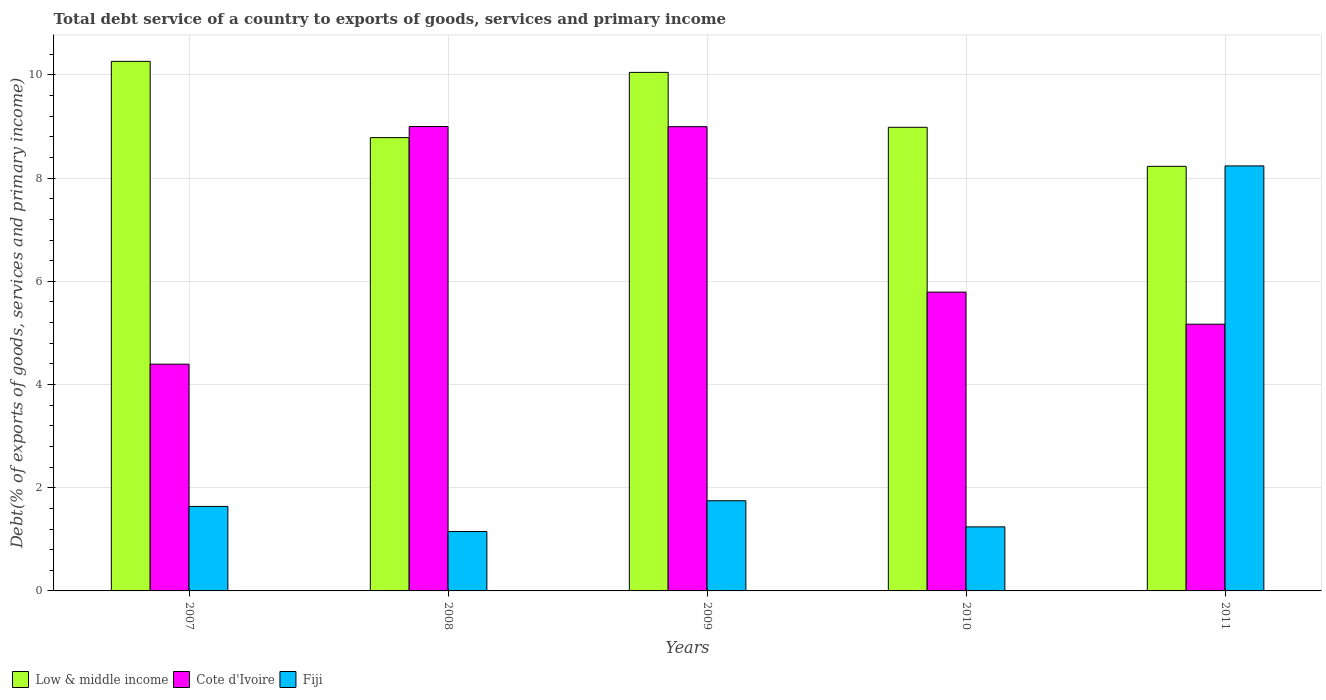How many groups of bars are there?
Your response must be concise. 5. Are the number of bars per tick equal to the number of legend labels?
Offer a terse response. Yes. How many bars are there on the 4th tick from the left?
Offer a very short reply. 3. What is the label of the 2nd group of bars from the left?
Make the answer very short. 2008. What is the total debt service in Cote d'Ivoire in 2009?
Provide a short and direct response. 9. Across all years, what is the maximum total debt service in Low & middle income?
Ensure brevity in your answer.  10.26. Across all years, what is the minimum total debt service in Low & middle income?
Your answer should be very brief. 8.23. In which year was the total debt service in Cote d'Ivoire minimum?
Your answer should be compact. 2007. What is the total total debt service in Fiji in the graph?
Provide a succinct answer. 14.02. What is the difference between the total debt service in Cote d'Ivoire in 2009 and that in 2010?
Provide a succinct answer. 3.21. What is the difference between the total debt service in Low & middle income in 2008 and the total debt service in Cote d'Ivoire in 2010?
Keep it short and to the point. 2.99. What is the average total debt service in Low & middle income per year?
Your answer should be very brief. 9.26. In the year 2007, what is the difference between the total debt service in Fiji and total debt service in Cote d'Ivoire?
Make the answer very short. -2.76. In how many years, is the total debt service in Cote d'Ivoire greater than 9.6 %?
Keep it short and to the point. 0. What is the ratio of the total debt service in Cote d'Ivoire in 2008 to that in 2011?
Make the answer very short. 1.74. What is the difference between the highest and the second highest total debt service in Fiji?
Ensure brevity in your answer.  6.49. What is the difference between the highest and the lowest total debt service in Fiji?
Your response must be concise. 7.09. Is the sum of the total debt service in Cote d'Ivoire in 2007 and 2011 greater than the maximum total debt service in Fiji across all years?
Keep it short and to the point. Yes. What does the 1st bar from the right in 2009 represents?
Your answer should be very brief. Fiji. What is the difference between two consecutive major ticks on the Y-axis?
Keep it short and to the point. 2. How many legend labels are there?
Offer a very short reply. 3. What is the title of the graph?
Offer a terse response. Total debt service of a country to exports of goods, services and primary income. What is the label or title of the Y-axis?
Your answer should be compact. Debt(% of exports of goods, services and primary income). What is the Debt(% of exports of goods, services and primary income) in Low & middle income in 2007?
Offer a very short reply. 10.26. What is the Debt(% of exports of goods, services and primary income) of Cote d'Ivoire in 2007?
Offer a terse response. 4.39. What is the Debt(% of exports of goods, services and primary income) of Fiji in 2007?
Make the answer very short. 1.64. What is the Debt(% of exports of goods, services and primary income) of Low & middle income in 2008?
Keep it short and to the point. 8.79. What is the Debt(% of exports of goods, services and primary income) in Cote d'Ivoire in 2008?
Make the answer very short. 9. What is the Debt(% of exports of goods, services and primary income) of Fiji in 2008?
Your answer should be very brief. 1.15. What is the Debt(% of exports of goods, services and primary income) of Low & middle income in 2009?
Your response must be concise. 10.05. What is the Debt(% of exports of goods, services and primary income) in Cote d'Ivoire in 2009?
Provide a short and direct response. 9. What is the Debt(% of exports of goods, services and primary income) in Fiji in 2009?
Make the answer very short. 1.75. What is the Debt(% of exports of goods, services and primary income) in Low & middle income in 2010?
Provide a short and direct response. 8.99. What is the Debt(% of exports of goods, services and primary income) of Cote d'Ivoire in 2010?
Provide a short and direct response. 5.79. What is the Debt(% of exports of goods, services and primary income) in Fiji in 2010?
Give a very brief answer. 1.24. What is the Debt(% of exports of goods, services and primary income) in Low & middle income in 2011?
Keep it short and to the point. 8.23. What is the Debt(% of exports of goods, services and primary income) of Cote d'Ivoire in 2011?
Make the answer very short. 5.17. What is the Debt(% of exports of goods, services and primary income) of Fiji in 2011?
Your answer should be very brief. 8.24. Across all years, what is the maximum Debt(% of exports of goods, services and primary income) of Low & middle income?
Provide a short and direct response. 10.26. Across all years, what is the maximum Debt(% of exports of goods, services and primary income) in Cote d'Ivoire?
Ensure brevity in your answer.  9. Across all years, what is the maximum Debt(% of exports of goods, services and primary income) of Fiji?
Provide a succinct answer. 8.24. Across all years, what is the minimum Debt(% of exports of goods, services and primary income) of Low & middle income?
Offer a terse response. 8.23. Across all years, what is the minimum Debt(% of exports of goods, services and primary income) in Cote d'Ivoire?
Offer a very short reply. 4.39. Across all years, what is the minimum Debt(% of exports of goods, services and primary income) in Fiji?
Give a very brief answer. 1.15. What is the total Debt(% of exports of goods, services and primary income) in Low & middle income in the graph?
Offer a terse response. 46.31. What is the total Debt(% of exports of goods, services and primary income) of Cote d'Ivoire in the graph?
Provide a short and direct response. 33.35. What is the total Debt(% of exports of goods, services and primary income) of Fiji in the graph?
Ensure brevity in your answer.  14.02. What is the difference between the Debt(% of exports of goods, services and primary income) in Low & middle income in 2007 and that in 2008?
Offer a very short reply. 1.48. What is the difference between the Debt(% of exports of goods, services and primary income) in Cote d'Ivoire in 2007 and that in 2008?
Ensure brevity in your answer.  -4.61. What is the difference between the Debt(% of exports of goods, services and primary income) of Fiji in 2007 and that in 2008?
Your response must be concise. 0.49. What is the difference between the Debt(% of exports of goods, services and primary income) in Low & middle income in 2007 and that in 2009?
Provide a succinct answer. 0.21. What is the difference between the Debt(% of exports of goods, services and primary income) of Cote d'Ivoire in 2007 and that in 2009?
Your answer should be very brief. -4.6. What is the difference between the Debt(% of exports of goods, services and primary income) of Fiji in 2007 and that in 2009?
Give a very brief answer. -0.11. What is the difference between the Debt(% of exports of goods, services and primary income) of Low & middle income in 2007 and that in 2010?
Provide a succinct answer. 1.28. What is the difference between the Debt(% of exports of goods, services and primary income) in Cote d'Ivoire in 2007 and that in 2010?
Provide a succinct answer. -1.4. What is the difference between the Debt(% of exports of goods, services and primary income) of Fiji in 2007 and that in 2010?
Your answer should be very brief. 0.4. What is the difference between the Debt(% of exports of goods, services and primary income) of Low & middle income in 2007 and that in 2011?
Provide a succinct answer. 2.03. What is the difference between the Debt(% of exports of goods, services and primary income) in Cote d'Ivoire in 2007 and that in 2011?
Your answer should be very brief. -0.77. What is the difference between the Debt(% of exports of goods, services and primary income) in Fiji in 2007 and that in 2011?
Offer a terse response. -6.6. What is the difference between the Debt(% of exports of goods, services and primary income) in Low & middle income in 2008 and that in 2009?
Offer a terse response. -1.26. What is the difference between the Debt(% of exports of goods, services and primary income) in Cote d'Ivoire in 2008 and that in 2009?
Your answer should be very brief. 0. What is the difference between the Debt(% of exports of goods, services and primary income) of Fiji in 2008 and that in 2009?
Provide a short and direct response. -0.6. What is the difference between the Debt(% of exports of goods, services and primary income) in Low & middle income in 2008 and that in 2010?
Offer a terse response. -0.2. What is the difference between the Debt(% of exports of goods, services and primary income) of Cote d'Ivoire in 2008 and that in 2010?
Provide a succinct answer. 3.21. What is the difference between the Debt(% of exports of goods, services and primary income) in Fiji in 2008 and that in 2010?
Ensure brevity in your answer.  -0.09. What is the difference between the Debt(% of exports of goods, services and primary income) in Low & middle income in 2008 and that in 2011?
Give a very brief answer. 0.56. What is the difference between the Debt(% of exports of goods, services and primary income) of Cote d'Ivoire in 2008 and that in 2011?
Keep it short and to the point. 3.83. What is the difference between the Debt(% of exports of goods, services and primary income) of Fiji in 2008 and that in 2011?
Keep it short and to the point. -7.09. What is the difference between the Debt(% of exports of goods, services and primary income) of Low & middle income in 2009 and that in 2010?
Your answer should be very brief. 1.06. What is the difference between the Debt(% of exports of goods, services and primary income) of Cote d'Ivoire in 2009 and that in 2010?
Provide a succinct answer. 3.21. What is the difference between the Debt(% of exports of goods, services and primary income) in Fiji in 2009 and that in 2010?
Offer a terse response. 0.51. What is the difference between the Debt(% of exports of goods, services and primary income) in Low & middle income in 2009 and that in 2011?
Keep it short and to the point. 1.82. What is the difference between the Debt(% of exports of goods, services and primary income) of Cote d'Ivoire in 2009 and that in 2011?
Your answer should be very brief. 3.83. What is the difference between the Debt(% of exports of goods, services and primary income) in Fiji in 2009 and that in 2011?
Your response must be concise. -6.49. What is the difference between the Debt(% of exports of goods, services and primary income) in Low & middle income in 2010 and that in 2011?
Offer a terse response. 0.76. What is the difference between the Debt(% of exports of goods, services and primary income) in Cote d'Ivoire in 2010 and that in 2011?
Make the answer very short. 0.62. What is the difference between the Debt(% of exports of goods, services and primary income) in Fiji in 2010 and that in 2011?
Your answer should be compact. -7. What is the difference between the Debt(% of exports of goods, services and primary income) of Low & middle income in 2007 and the Debt(% of exports of goods, services and primary income) of Cote d'Ivoire in 2008?
Your response must be concise. 1.26. What is the difference between the Debt(% of exports of goods, services and primary income) of Low & middle income in 2007 and the Debt(% of exports of goods, services and primary income) of Fiji in 2008?
Offer a very short reply. 9.11. What is the difference between the Debt(% of exports of goods, services and primary income) in Cote d'Ivoire in 2007 and the Debt(% of exports of goods, services and primary income) in Fiji in 2008?
Make the answer very short. 3.24. What is the difference between the Debt(% of exports of goods, services and primary income) in Low & middle income in 2007 and the Debt(% of exports of goods, services and primary income) in Cote d'Ivoire in 2009?
Make the answer very short. 1.27. What is the difference between the Debt(% of exports of goods, services and primary income) of Low & middle income in 2007 and the Debt(% of exports of goods, services and primary income) of Fiji in 2009?
Make the answer very short. 8.52. What is the difference between the Debt(% of exports of goods, services and primary income) of Cote d'Ivoire in 2007 and the Debt(% of exports of goods, services and primary income) of Fiji in 2009?
Your response must be concise. 2.65. What is the difference between the Debt(% of exports of goods, services and primary income) in Low & middle income in 2007 and the Debt(% of exports of goods, services and primary income) in Cote d'Ivoire in 2010?
Keep it short and to the point. 4.47. What is the difference between the Debt(% of exports of goods, services and primary income) of Low & middle income in 2007 and the Debt(% of exports of goods, services and primary income) of Fiji in 2010?
Give a very brief answer. 9.02. What is the difference between the Debt(% of exports of goods, services and primary income) in Cote d'Ivoire in 2007 and the Debt(% of exports of goods, services and primary income) in Fiji in 2010?
Provide a succinct answer. 3.15. What is the difference between the Debt(% of exports of goods, services and primary income) in Low & middle income in 2007 and the Debt(% of exports of goods, services and primary income) in Cote d'Ivoire in 2011?
Your response must be concise. 5.09. What is the difference between the Debt(% of exports of goods, services and primary income) of Low & middle income in 2007 and the Debt(% of exports of goods, services and primary income) of Fiji in 2011?
Provide a short and direct response. 2.03. What is the difference between the Debt(% of exports of goods, services and primary income) in Cote d'Ivoire in 2007 and the Debt(% of exports of goods, services and primary income) in Fiji in 2011?
Your answer should be compact. -3.84. What is the difference between the Debt(% of exports of goods, services and primary income) of Low & middle income in 2008 and the Debt(% of exports of goods, services and primary income) of Cote d'Ivoire in 2009?
Provide a short and direct response. -0.21. What is the difference between the Debt(% of exports of goods, services and primary income) in Low & middle income in 2008 and the Debt(% of exports of goods, services and primary income) in Fiji in 2009?
Provide a short and direct response. 7.04. What is the difference between the Debt(% of exports of goods, services and primary income) in Cote d'Ivoire in 2008 and the Debt(% of exports of goods, services and primary income) in Fiji in 2009?
Your answer should be very brief. 7.25. What is the difference between the Debt(% of exports of goods, services and primary income) of Low & middle income in 2008 and the Debt(% of exports of goods, services and primary income) of Cote d'Ivoire in 2010?
Offer a terse response. 2.99. What is the difference between the Debt(% of exports of goods, services and primary income) in Low & middle income in 2008 and the Debt(% of exports of goods, services and primary income) in Fiji in 2010?
Your answer should be compact. 7.54. What is the difference between the Debt(% of exports of goods, services and primary income) in Cote d'Ivoire in 2008 and the Debt(% of exports of goods, services and primary income) in Fiji in 2010?
Your answer should be very brief. 7.76. What is the difference between the Debt(% of exports of goods, services and primary income) of Low & middle income in 2008 and the Debt(% of exports of goods, services and primary income) of Cote d'Ivoire in 2011?
Your response must be concise. 3.62. What is the difference between the Debt(% of exports of goods, services and primary income) of Low & middle income in 2008 and the Debt(% of exports of goods, services and primary income) of Fiji in 2011?
Offer a terse response. 0.55. What is the difference between the Debt(% of exports of goods, services and primary income) of Cote d'Ivoire in 2008 and the Debt(% of exports of goods, services and primary income) of Fiji in 2011?
Offer a terse response. 0.76. What is the difference between the Debt(% of exports of goods, services and primary income) in Low & middle income in 2009 and the Debt(% of exports of goods, services and primary income) in Cote d'Ivoire in 2010?
Your answer should be very brief. 4.26. What is the difference between the Debt(% of exports of goods, services and primary income) in Low & middle income in 2009 and the Debt(% of exports of goods, services and primary income) in Fiji in 2010?
Offer a terse response. 8.81. What is the difference between the Debt(% of exports of goods, services and primary income) in Cote d'Ivoire in 2009 and the Debt(% of exports of goods, services and primary income) in Fiji in 2010?
Your answer should be very brief. 7.76. What is the difference between the Debt(% of exports of goods, services and primary income) in Low & middle income in 2009 and the Debt(% of exports of goods, services and primary income) in Cote d'Ivoire in 2011?
Make the answer very short. 4.88. What is the difference between the Debt(% of exports of goods, services and primary income) in Low & middle income in 2009 and the Debt(% of exports of goods, services and primary income) in Fiji in 2011?
Offer a very short reply. 1.81. What is the difference between the Debt(% of exports of goods, services and primary income) of Cote d'Ivoire in 2009 and the Debt(% of exports of goods, services and primary income) of Fiji in 2011?
Your answer should be compact. 0.76. What is the difference between the Debt(% of exports of goods, services and primary income) in Low & middle income in 2010 and the Debt(% of exports of goods, services and primary income) in Cote d'Ivoire in 2011?
Offer a very short reply. 3.82. What is the difference between the Debt(% of exports of goods, services and primary income) in Low & middle income in 2010 and the Debt(% of exports of goods, services and primary income) in Fiji in 2011?
Provide a short and direct response. 0.75. What is the difference between the Debt(% of exports of goods, services and primary income) in Cote d'Ivoire in 2010 and the Debt(% of exports of goods, services and primary income) in Fiji in 2011?
Your answer should be compact. -2.45. What is the average Debt(% of exports of goods, services and primary income) in Low & middle income per year?
Your answer should be compact. 9.26. What is the average Debt(% of exports of goods, services and primary income) in Cote d'Ivoire per year?
Your response must be concise. 6.67. What is the average Debt(% of exports of goods, services and primary income) of Fiji per year?
Ensure brevity in your answer.  2.8. In the year 2007, what is the difference between the Debt(% of exports of goods, services and primary income) in Low & middle income and Debt(% of exports of goods, services and primary income) in Cote d'Ivoire?
Offer a terse response. 5.87. In the year 2007, what is the difference between the Debt(% of exports of goods, services and primary income) in Low & middle income and Debt(% of exports of goods, services and primary income) in Fiji?
Make the answer very short. 8.63. In the year 2007, what is the difference between the Debt(% of exports of goods, services and primary income) in Cote d'Ivoire and Debt(% of exports of goods, services and primary income) in Fiji?
Your answer should be very brief. 2.76. In the year 2008, what is the difference between the Debt(% of exports of goods, services and primary income) in Low & middle income and Debt(% of exports of goods, services and primary income) in Cote d'Ivoire?
Offer a terse response. -0.22. In the year 2008, what is the difference between the Debt(% of exports of goods, services and primary income) in Low & middle income and Debt(% of exports of goods, services and primary income) in Fiji?
Give a very brief answer. 7.63. In the year 2008, what is the difference between the Debt(% of exports of goods, services and primary income) of Cote d'Ivoire and Debt(% of exports of goods, services and primary income) of Fiji?
Ensure brevity in your answer.  7.85. In the year 2009, what is the difference between the Debt(% of exports of goods, services and primary income) in Low & middle income and Debt(% of exports of goods, services and primary income) in Cote d'Ivoire?
Offer a very short reply. 1.05. In the year 2009, what is the difference between the Debt(% of exports of goods, services and primary income) in Low & middle income and Debt(% of exports of goods, services and primary income) in Fiji?
Ensure brevity in your answer.  8.3. In the year 2009, what is the difference between the Debt(% of exports of goods, services and primary income) of Cote d'Ivoire and Debt(% of exports of goods, services and primary income) of Fiji?
Provide a succinct answer. 7.25. In the year 2010, what is the difference between the Debt(% of exports of goods, services and primary income) in Low & middle income and Debt(% of exports of goods, services and primary income) in Cote d'Ivoire?
Provide a succinct answer. 3.19. In the year 2010, what is the difference between the Debt(% of exports of goods, services and primary income) in Low & middle income and Debt(% of exports of goods, services and primary income) in Fiji?
Offer a terse response. 7.74. In the year 2010, what is the difference between the Debt(% of exports of goods, services and primary income) in Cote d'Ivoire and Debt(% of exports of goods, services and primary income) in Fiji?
Offer a terse response. 4.55. In the year 2011, what is the difference between the Debt(% of exports of goods, services and primary income) in Low & middle income and Debt(% of exports of goods, services and primary income) in Cote d'Ivoire?
Ensure brevity in your answer.  3.06. In the year 2011, what is the difference between the Debt(% of exports of goods, services and primary income) in Low & middle income and Debt(% of exports of goods, services and primary income) in Fiji?
Your answer should be very brief. -0.01. In the year 2011, what is the difference between the Debt(% of exports of goods, services and primary income) in Cote d'Ivoire and Debt(% of exports of goods, services and primary income) in Fiji?
Keep it short and to the point. -3.07. What is the ratio of the Debt(% of exports of goods, services and primary income) in Low & middle income in 2007 to that in 2008?
Give a very brief answer. 1.17. What is the ratio of the Debt(% of exports of goods, services and primary income) in Cote d'Ivoire in 2007 to that in 2008?
Offer a terse response. 0.49. What is the ratio of the Debt(% of exports of goods, services and primary income) of Fiji in 2007 to that in 2008?
Provide a succinct answer. 1.42. What is the ratio of the Debt(% of exports of goods, services and primary income) of Low & middle income in 2007 to that in 2009?
Give a very brief answer. 1.02. What is the ratio of the Debt(% of exports of goods, services and primary income) of Cote d'Ivoire in 2007 to that in 2009?
Your answer should be compact. 0.49. What is the ratio of the Debt(% of exports of goods, services and primary income) in Fiji in 2007 to that in 2009?
Ensure brevity in your answer.  0.94. What is the ratio of the Debt(% of exports of goods, services and primary income) of Low & middle income in 2007 to that in 2010?
Provide a succinct answer. 1.14. What is the ratio of the Debt(% of exports of goods, services and primary income) in Cote d'Ivoire in 2007 to that in 2010?
Provide a succinct answer. 0.76. What is the ratio of the Debt(% of exports of goods, services and primary income) in Fiji in 2007 to that in 2010?
Give a very brief answer. 1.32. What is the ratio of the Debt(% of exports of goods, services and primary income) of Low & middle income in 2007 to that in 2011?
Provide a short and direct response. 1.25. What is the ratio of the Debt(% of exports of goods, services and primary income) in Cote d'Ivoire in 2007 to that in 2011?
Your answer should be very brief. 0.85. What is the ratio of the Debt(% of exports of goods, services and primary income) in Fiji in 2007 to that in 2011?
Ensure brevity in your answer.  0.2. What is the ratio of the Debt(% of exports of goods, services and primary income) of Low & middle income in 2008 to that in 2009?
Your answer should be very brief. 0.87. What is the ratio of the Debt(% of exports of goods, services and primary income) in Fiji in 2008 to that in 2009?
Your response must be concise. 0.66. What is the ratio of the Debt(% of exports of goods, services and primary income) in Low & middle income in 2008 to that in 2010?
Provide a short and direct response. 0.98. What is the ratio of the Debt(% of exports of goods, services and primary income) in Cote d'Ivoire in 2008 to that in 2010?
Ensure brevity in your answer.  1.55. What is the ratio of the Debt(% of exports of goods, services and primary income) of Fiji in 2008 to that in 2010?
Provide a short and direct response. 0.93. What is the ratio of the Debt(% of exports of goods, services and primary income) of Low & middle income in 2008 to that in 2011?
Your answer should be compact. 1.07. What is the ratio of the Debt(% of exports of goods, services and primary income) of Cote d'Ivoire in 2008 to that in 2011?
Make the answer very short. 1.74. What is the ratio of the Debt(% of exports of goods, services and primary income) in Fiji in 2008 to that in 2011?
Offer a very short reply. 0.14. What is the ratio of the Debt(% of exports of goods, services and primary income) of Low & middle income in 2009 to that in 2010?
Make the answer very short. 1.12. What is the ratio of the Debt(% of exports of goods, services and primary income) of Cote d'Ivoire in 2009 to that in 2010?
Your response must be concise. 1.55. What is the ratio of the Debt(% of exports of goods, services and primary income) of Fiji in 2009 to that in 2010?
Offer a terse response. 1.41. What is the ratio of the Debt(% of exports of goods, services and primary income) in Low & middle income in 2009 to that in 2011?
Keep it short and to the point. 1.22. What is the ratio of the Debt(% of exports of goods, services and primary income) of Cote d'Ivoire in 2009 to that in 2011?
Your answer should be compact. 1.74. What is the ratio of the Debt(% of exports of goods, services and primary income) in Fiji in 2009 to that in 2011?
Make the answer very short. 0.21. What is the ratio of the Debt(% of exports of goods, services and primary income) of Low & middle income in 2010 to that in 2011?
Make the answer very short. 1.09. What is the ratio of the Debt(% of exports of goods, services and primary income) in Cote d'Ivoire in 2010 to that in 2011?
Keep it short and to the point. 1.12. What is the ratio of the Debt(% of exports of goods, services and primary income) in Fiji in 2010 to that in 2011?
Provide a succinct answer. 0.15. What is the difference between the highest and the second highest Debt(% of exports of goods, services and primary income) in Low & middle income?
Provide a short and direct response. 0.21. What is the difference between the highest and the second highest Debt(% of exports of goods, services and primary income) in Cote d'Ivoire?
Make the answer very short. 0. What is the difference between the highest and the second highest Debt(% of exports of goods, services and primary income) in Fiji?
Keep it short and to the point. 6.49. What is the difference between the highest and the lowest Debt(% of exports of goods, services and primary income) of Low & middle income?
Offer a terse response. 2.03. What is the difference between the highest and the lowest Debt(% of exports of goods, services and primary income) in Cote d'Ivoire?
Your answer should be compact. 4.61. What is the difference between the highest and the lowest Debt(% of exports of goods, services and primary income) in Fiji?
Keep it short and to the point. 7.09. 